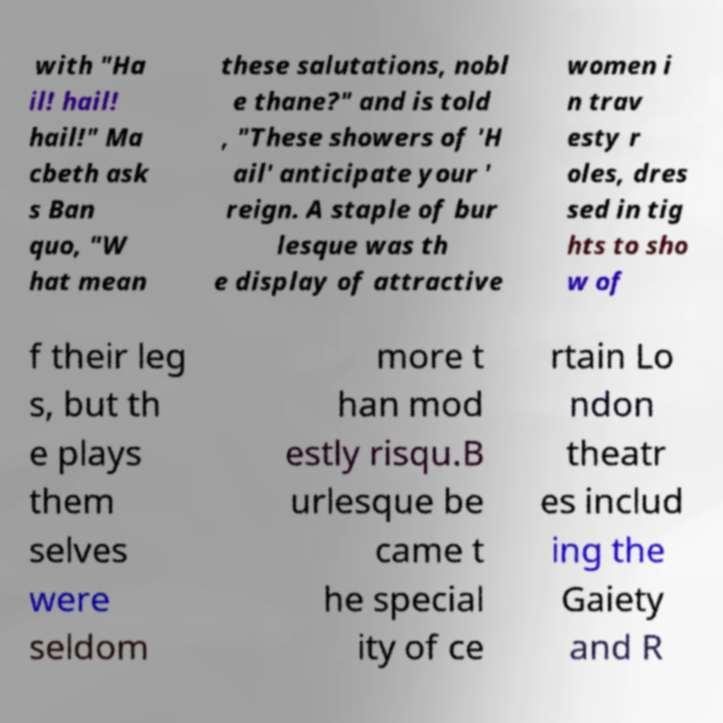I need the written content from this picture converted into text. Can you do that? with "Ha il! hail! hail!" Ma cbeth ask s Ban quo, "W hat mean these salutations, nobl e thane?" and is told , "These showers of 'H ail' anticipate your ' reign. A staple of bur lesque was th e display of attractive women i n trav esty r oles, dres sed in tig hts to sho w of f their leg s, but th e plays them selves were seldom more t han mod estly risqu.B urlesque be came t he special ity of ce rtain Lo ndon theatr es includ ing the Gaiety and R 